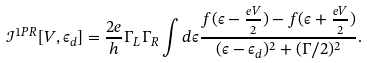<formula> <loc_0><loc_0><loc_500><loc_500>\mathcal { I } ^ { 1 P R } [ V , \epsilon _ { d } ] = \frac { 2 e } { h } \Gamma _ { L } \Gamma _ { R } \int d \epsilon \frac { f ( \epsilon - \frac { e V } { 2 } ) - f ( \epsilon + \frac { e V } { 2 } ) } { ( \epsilon - \epsilon _ { d } ) ^ { 2 } + ( \Gamma / 2 ) ^ { 2 } } .</formula> 